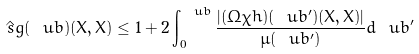<formula> <loc_0><loc_0><loc_500><loc_500>\hat { \ s g } ( \ u b ) ( X , X ) \leq 1 + 2 \int _ { 0 } ^ { \ u b } \frac { | ( \Omega \chi h ) ( \ u b ^ { \prime } ) ( X , X ) | } { \mu ( \ u b ^ { \prime } ) } d \ u b ^ { \prime }</formula> 